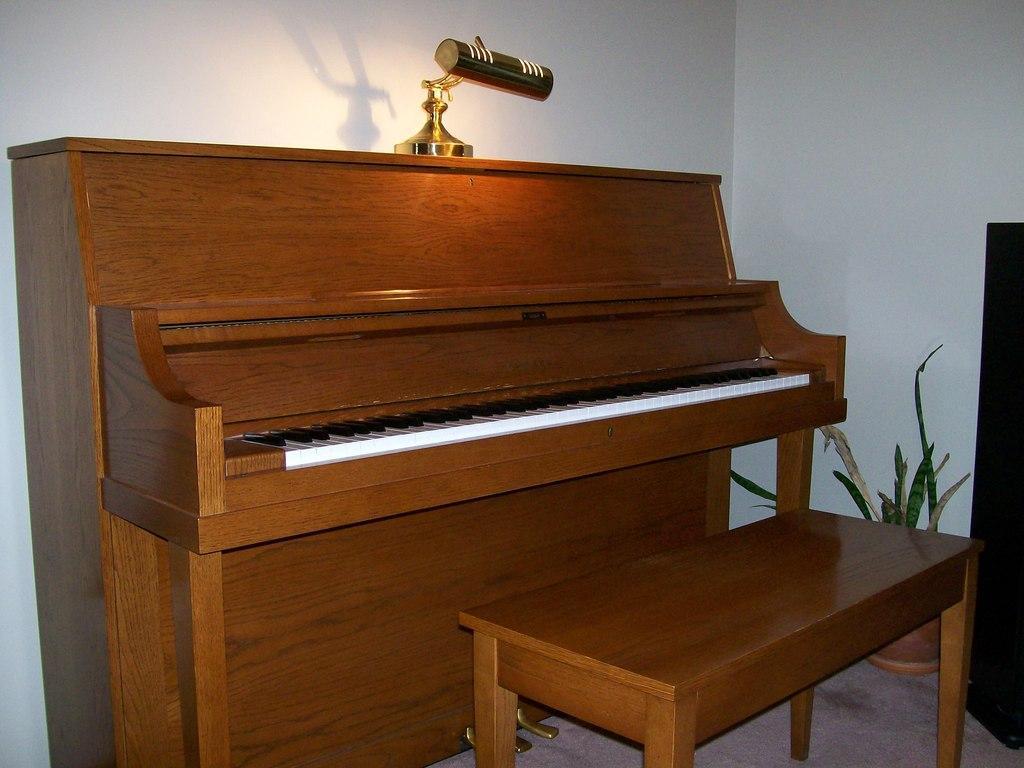Describe this image in one or two sentences. There is a piano table. In front of the table there is a bench. On the table there is a lamp. Into the right side corner there is a pot with the plant. 